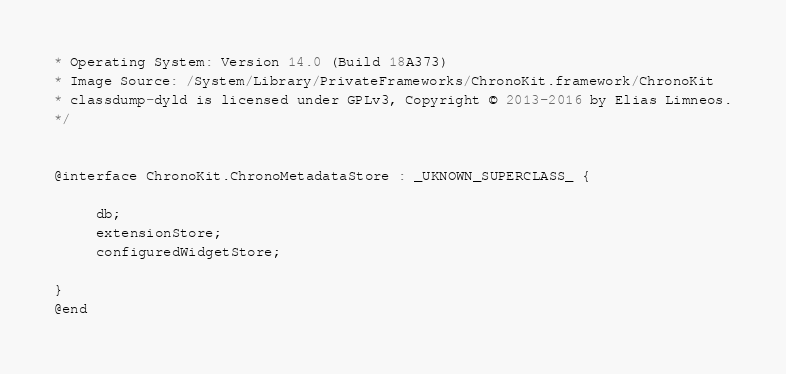Convert code to text. <code><loc_0><loc_0><loc_500><loc_500><_C_>* Operating System: Version 14.0 (Build 18A373)
* Image Source: /System/Library/PrivateFrameworks/ChronoKit.framework/ChronoKit
* classdump-dyld is licensed under GPLv3, Copyright © 2013-2016 by Elias Limneos.
*/


@interface ChronoKit.ChronoMetadataStore : _UKNOWN_SUPERCLASS_ {

	 db;
	 extensionStore;
	 configuredWidgetStore;

}
@end

</code> 